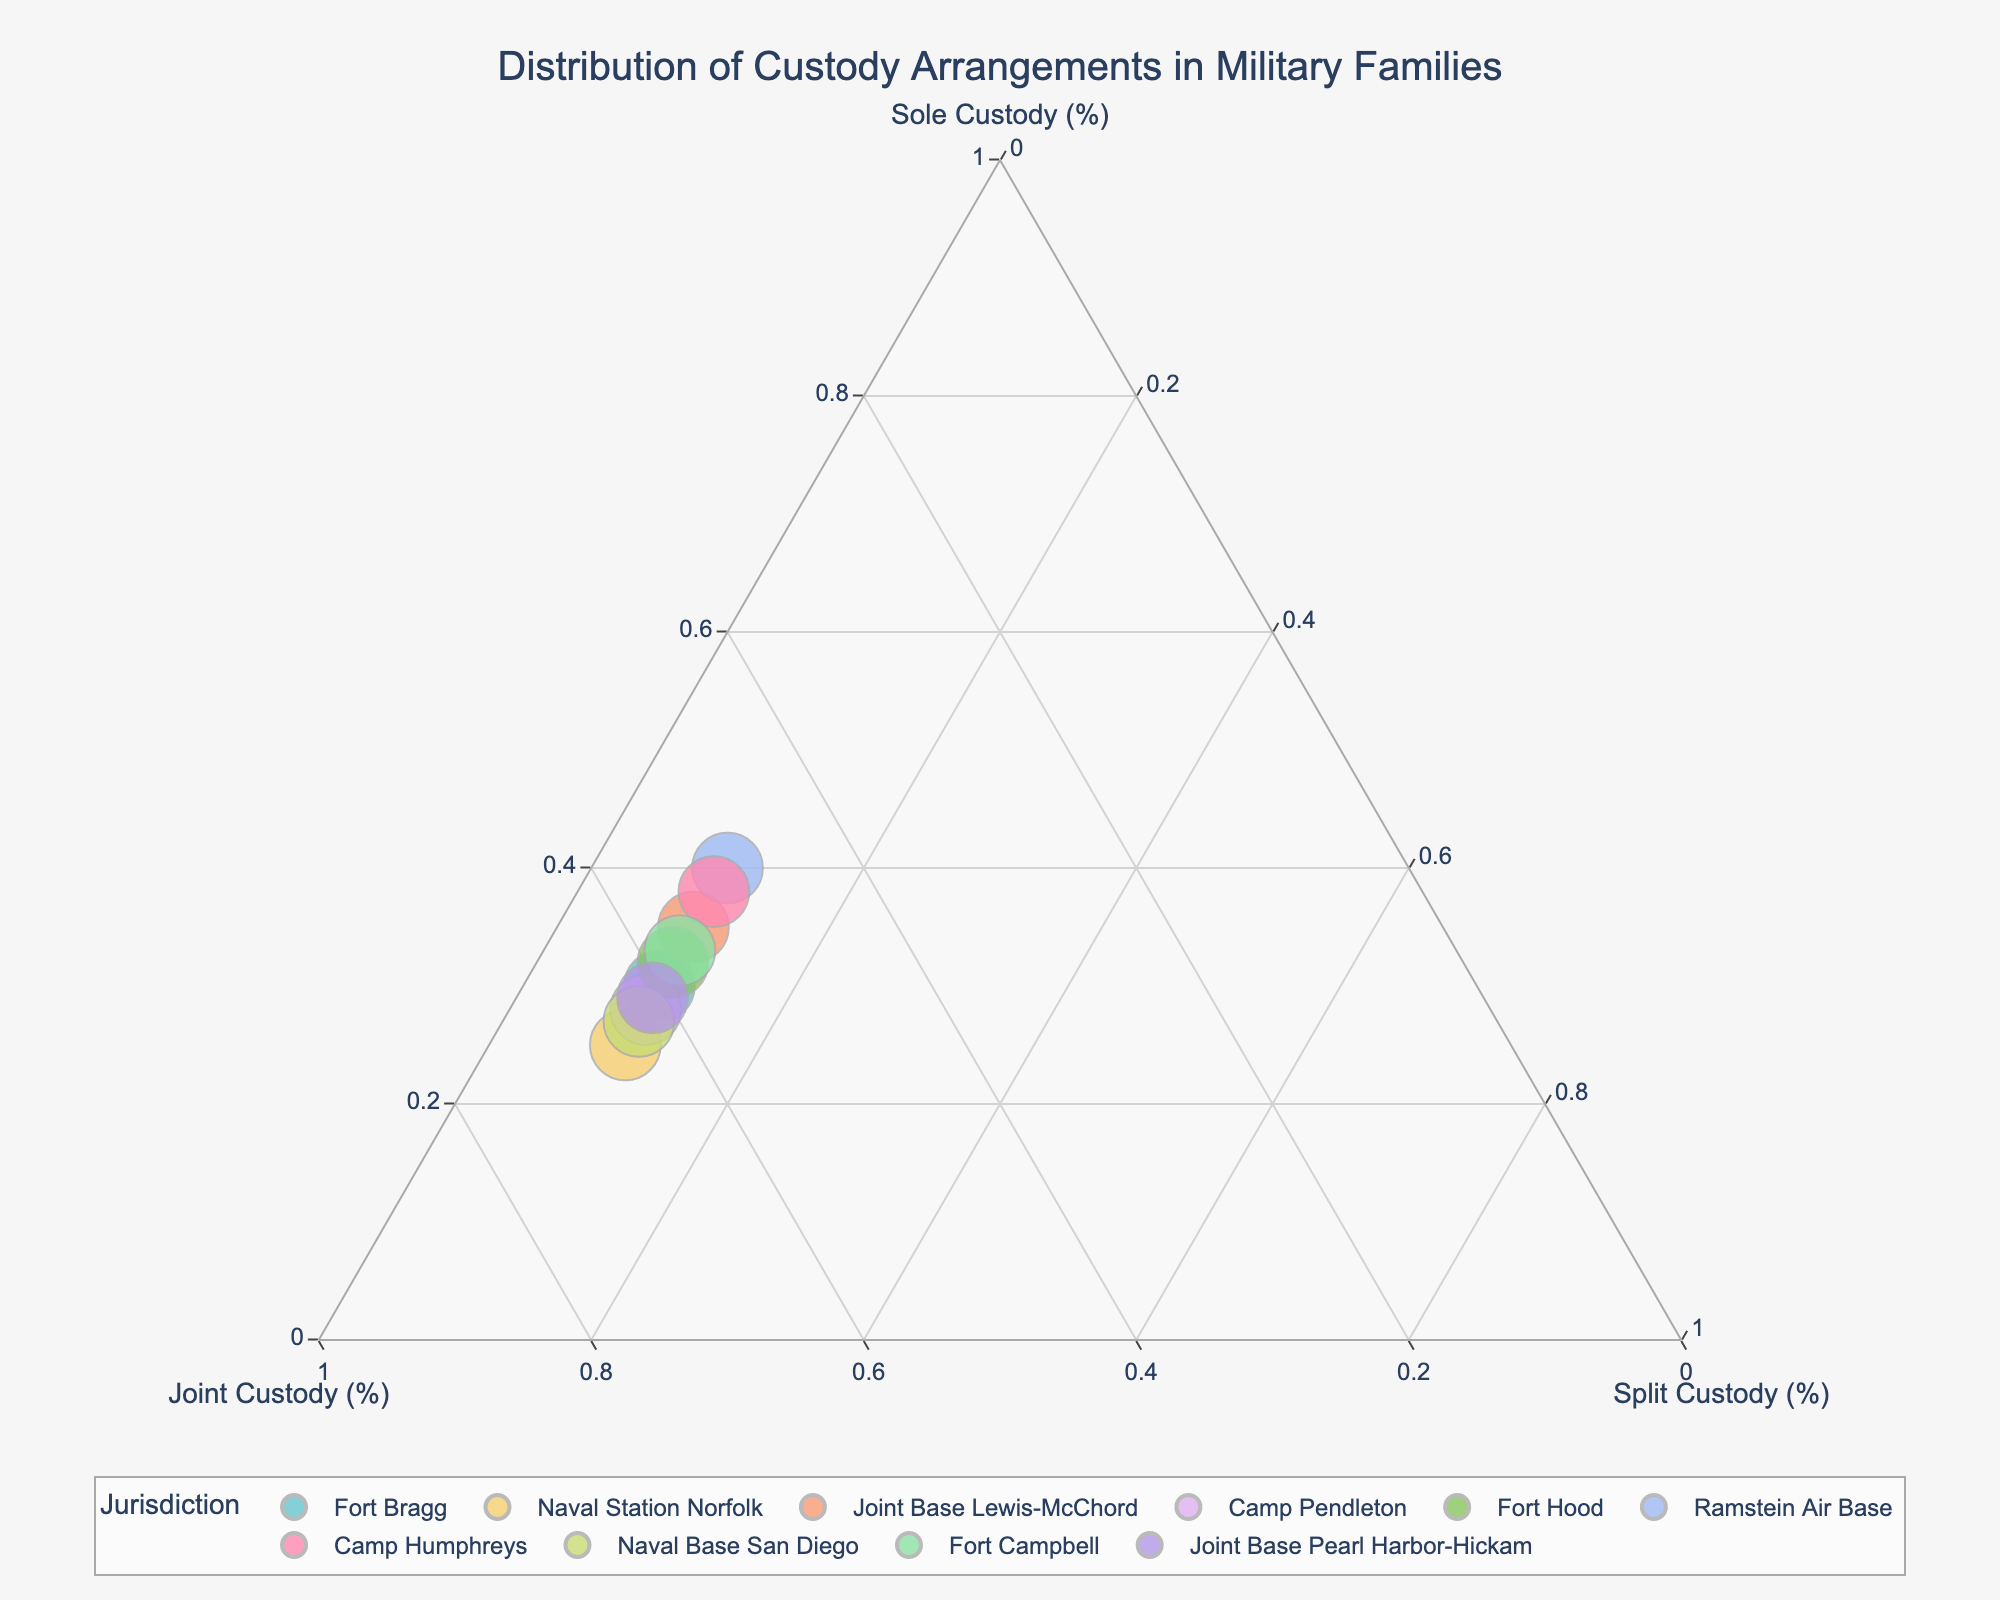What's the title of the figure? The title is usually displayed at the top of the figure. By looking at the top, you'll see the title "Distribution of Custody Arrangements in Military Families".
Answer: Distribution of Custody Arrangements in Military Families Which custody arrangement category has the highest percentage in Fort Bragg? Locate Fort Bragg on the plot by hovering over the point. You can see the percentages of each custody arrangement. Joint Custody has the highest percentage at 60%.
Answer: Joint Custody How does the custody distribution at Camp Pendleton compare to that at Naval Base San Diego? Locate both Camp Pendleton and Naval Base San Diego on the plot. Camp Pendleton has 28% Sole, 62% Joint, and 10% Split Custody while Naval Base San Diego has 27% Sole, 63% Joint, and 10% Split Custody. This shows they are very similar in distribution percentages.
Answer: Very similar Which jurisdiction has the highest percentage of Sole Custody? Look for the point furthest along the Sole Custody axis. Ramstein Air Base is at 40% Sole Custody, which is the highest among the jurisdictions.
Answer: Ramstein Air Base Identify the jurisdiction with the lowest percentage of Joint Custody. Locate the point that is closest to the opposite end of the Joint Custody axis. Ramstein Air Base has 50% Joint Custody, which is the lowest percentage shown.
Answer: Ramstein Air Base What is the median percentage of Joint Custody among all jurisdictions? Extract Joint Custody percentages and order them: 55, 57, 58, 60, 61, 62, 63, 65. Median is the middle value, which is (60 + 61)/2 = 60.5.
Answer: 60.5 Which jurisdiction has an equal percentage in Sole and Joint Custody categories? Compare all points to find one where Sole and Joint Custody percentages are equal. None of the jurisdictions in the provided data set have equal percentages for Sole and Joint Custody.
Answer: None What are the custody arrangements at Joint Base Lewis-McChord? Locate Joint Base Lewis-McChord in the plot, hover over it to see its data: 35% Sole Custody, 55% Joint Custody, and 10% Split Custody.
Answer: 35% Sole, 55% Joint, 10% Split Is there a trend in Sole Custody percentages among jurisdictions? Observe the Sole Custody percentages. They vary significantly between 25% and 40% and do not follow a clear increasing or decreasing trend.
Answer: No clear trend Which custody arrangement percentages remain constant across all jurisdictions? By looking at all data points in the plot, you'll notice that Split Custody percentages are consistently at 10% for all jurisdictions.
Answer: Split Custody 